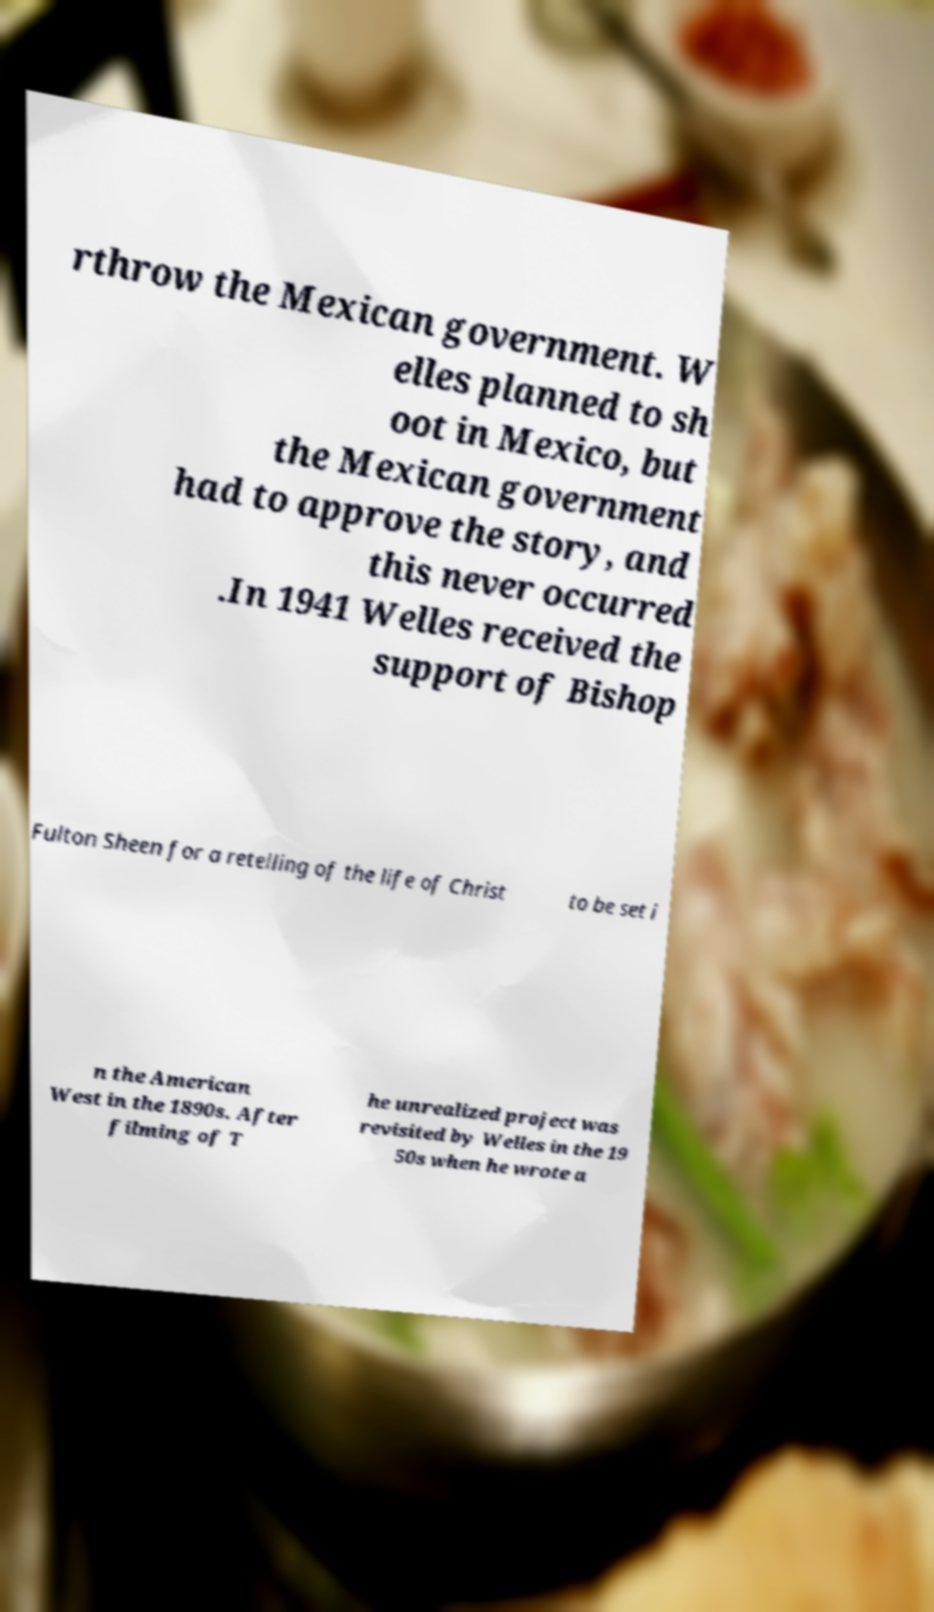For documentation purposes, I need the text within this image transcribed. Could you provide that? rthrow the Mexican government. W elles planned to sh oot in Mexico, but the Mexican government had to approve the story, and this never occurred .In 1941 Welles received the support of Bishop Fulton Sheen for a retelling of the life of Christ to be set i n the American West in the 1890s. After filming of T he unrealized project was revisited by Welles in the 19 50s when he wrote a 